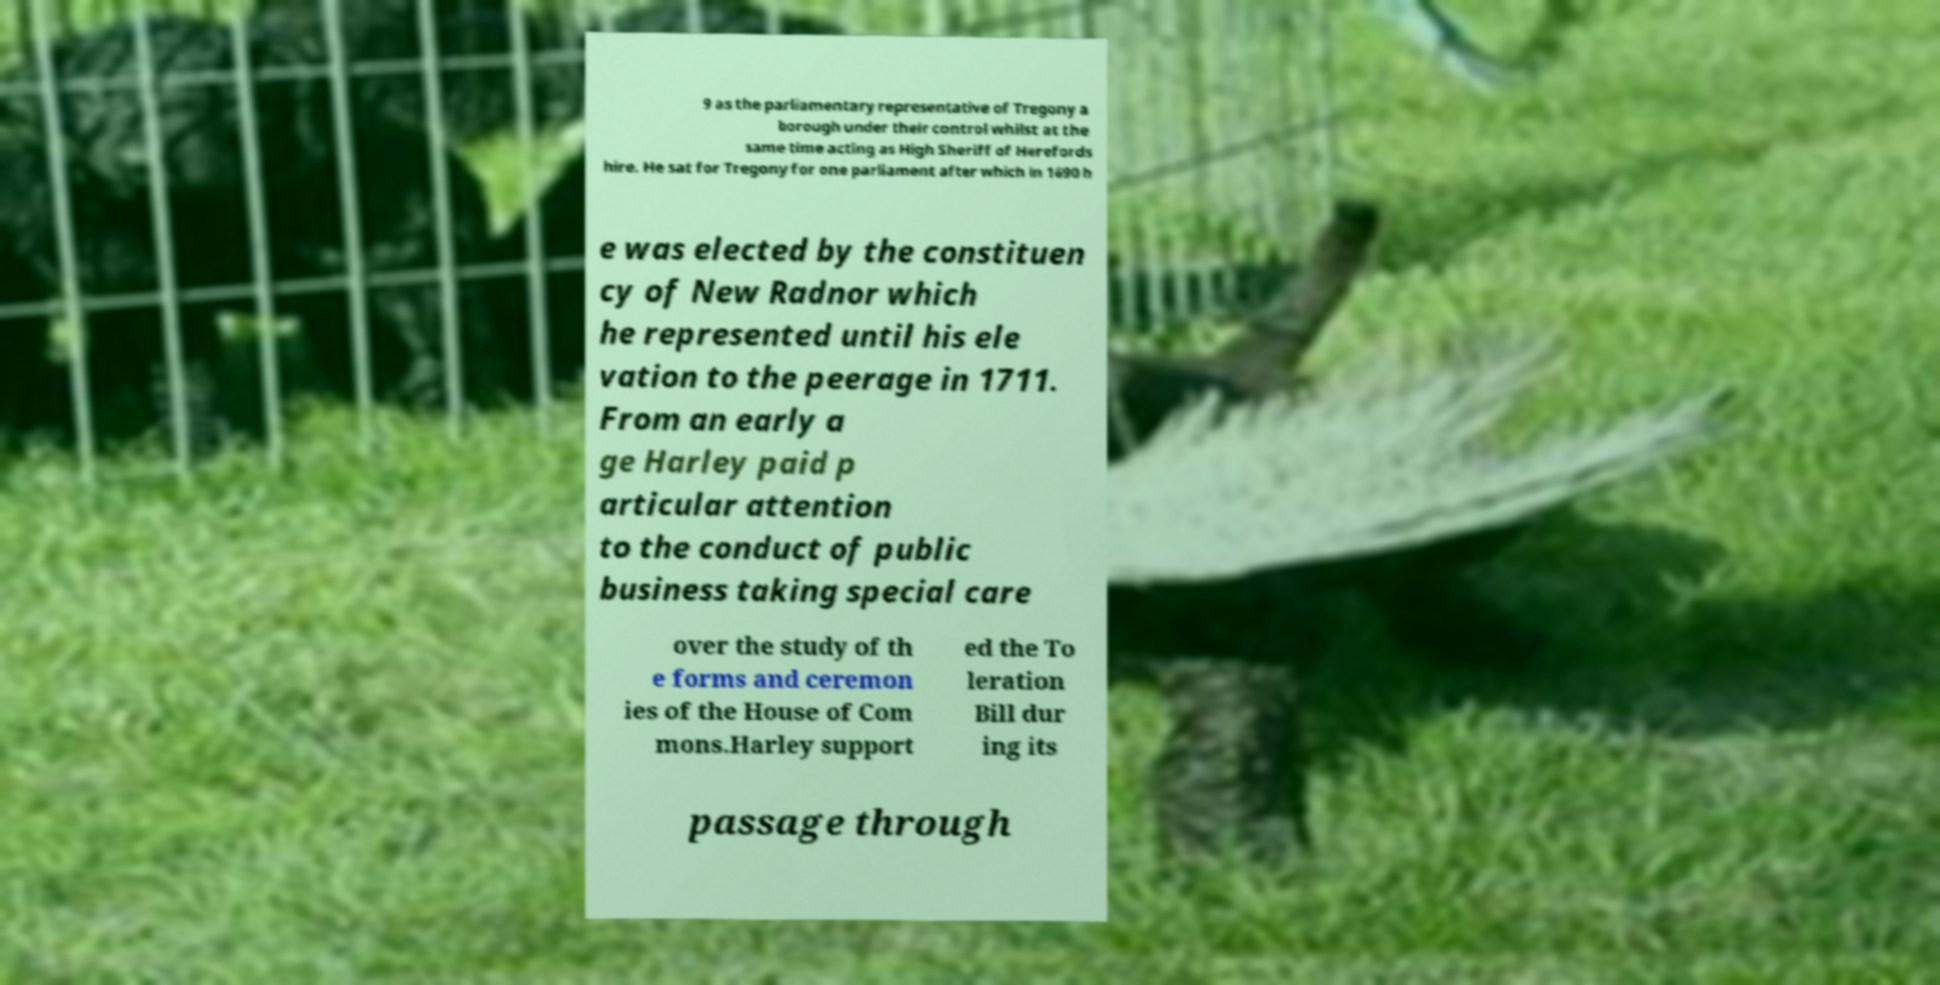Please identify and transcribe the text found in this image. 9 as the parliamentary representative of Tregony a borough under their control whilst at the same time acting as High Sheriff of Herefords hire. He sat for Tregony for one parliament after which in 1690 h e was elected by the constituen cy of New Radnor which he represented until his ele vation to the peerage in 1711. From an early a ge Harley paid p articular attention to the conduct of public business taking special care over the study of th e forms and ceremon ies of the House of Com mons.Harley support ed the To leration Bill dur ing its passage through 